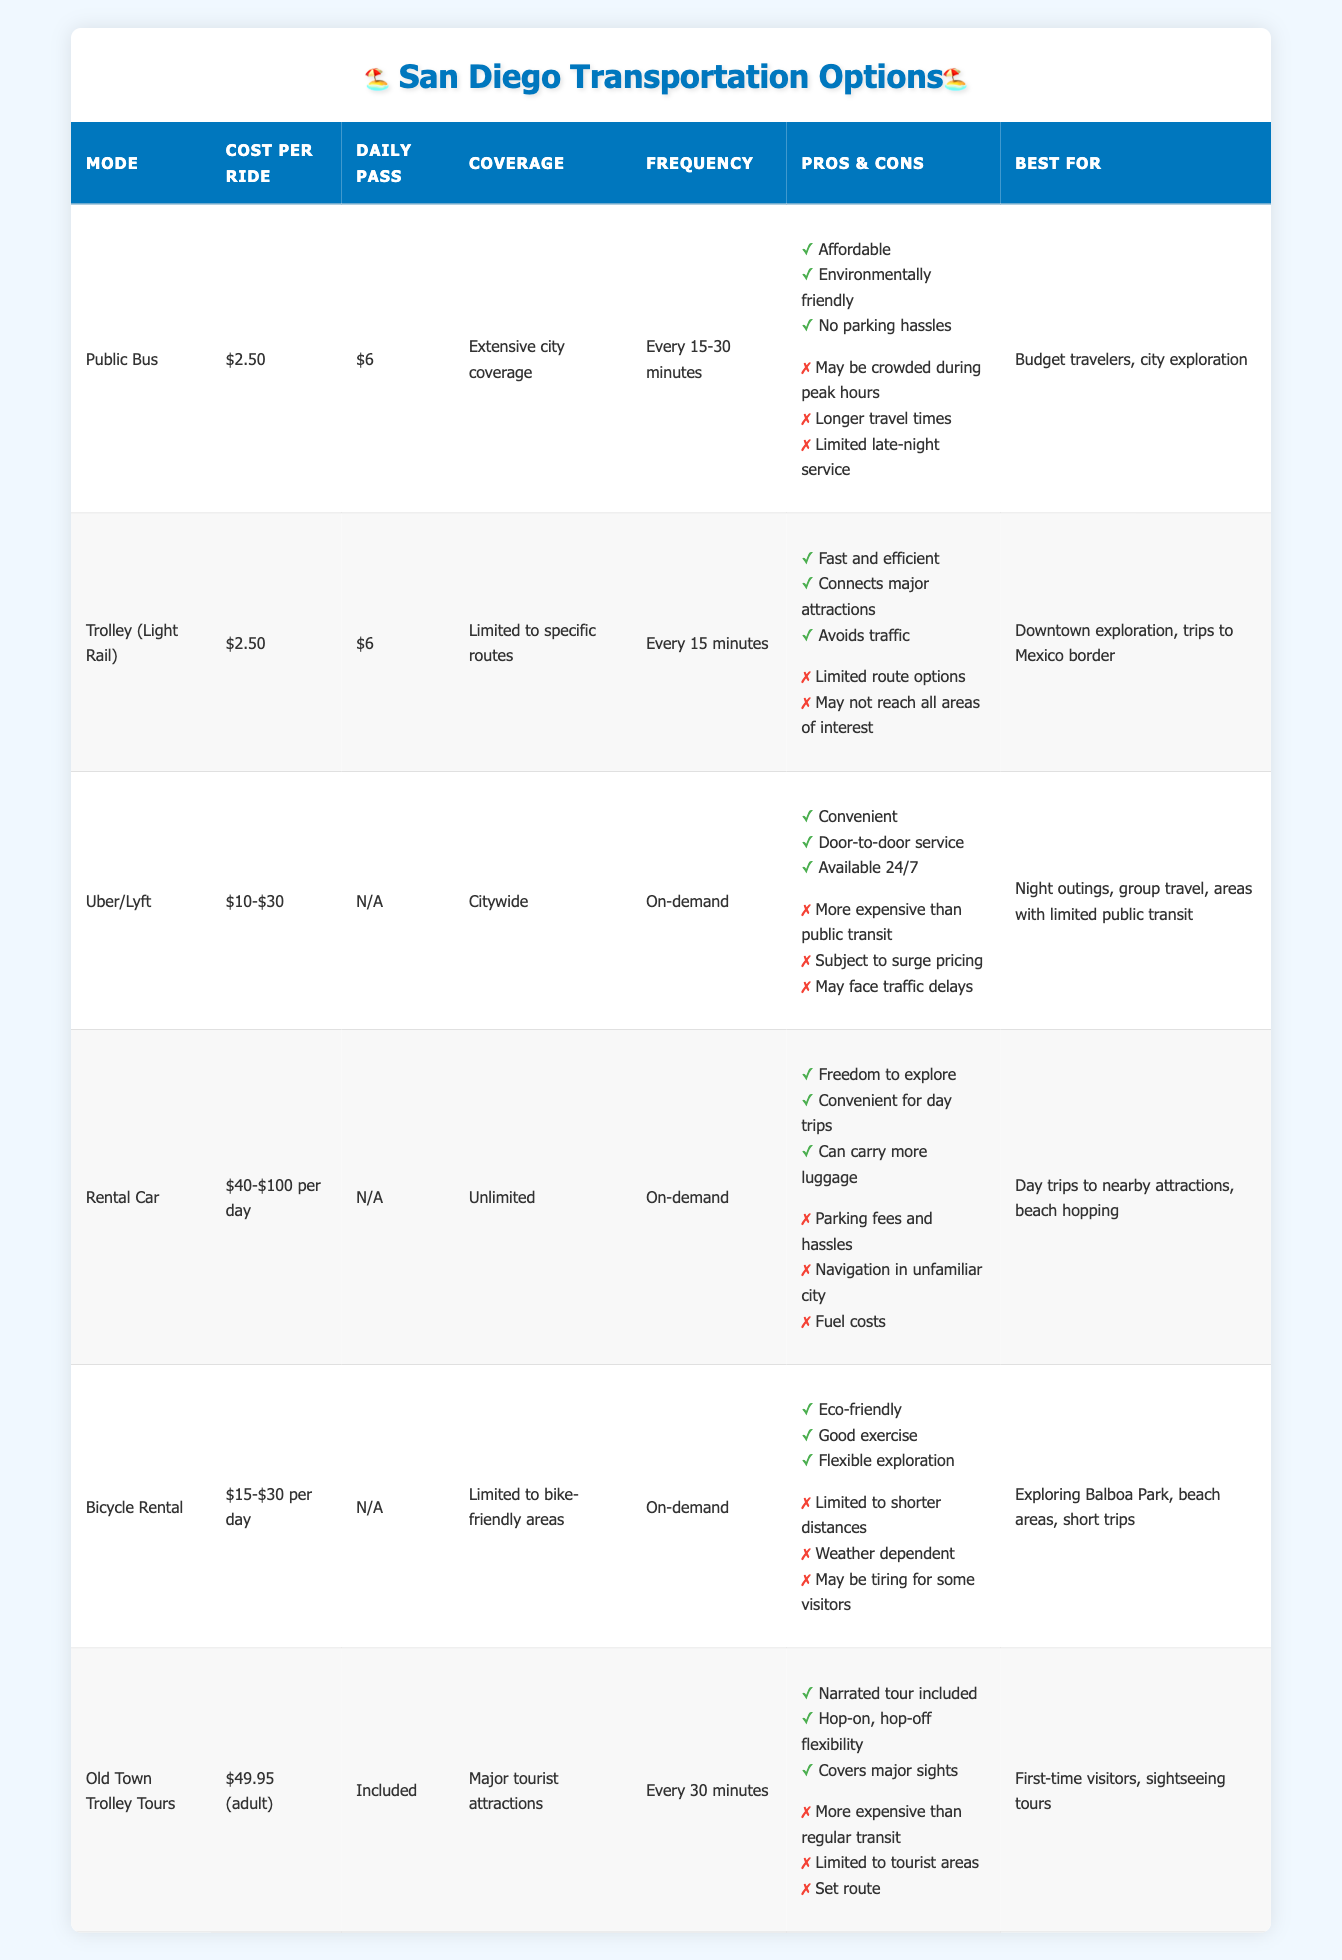What is the cost per ride for the Public Bus? Referring to the table under the "Cost per Ride" column for the row labeled "Public Bus," the value given is $2.50.
Answer: $2.50 Which transportation option has the highest cost per ride? Looking at the "Cost per Ride" column, the highest value is found in the "Rental Car" row, which lists $40-$100 per day. This is greater than all other options.
Answer: Rental Car Does the Trolley (Light Rail) have daily passes? By checking the "Daily Pass" column for the "Trolley (Light Rail)" row, it shows $6, which indicates that it does have a daily pass option available.
Answer: Yes What is the frequency of the Old Town Trolley Tours? In the table under the “Frequency” column, the frequency for "Old Town Trolley Tours" is listed as "Every 30 minutes."
Answer: Every 30 minutes How much more expensive is the Uber/Lyft service compared to the Public Bus cost per ride? The cost for Uber/Lyft is between $10 and $30, while the Public Bus is $2.50. Taking the lowest Uber/Lyft cost of $10 and subtracting the Public Bus cost gives $10 - $2.50 = $7.50. The highest difference with $30 would be $30 - $2.50 = $27.50. Thus, Uber/Lyft is between $7.50 and $27.50 more expensive than the Public Bus.
Answer: $7.50 to $27.50 Which transportation option is best for sightseeing tours? By looking at the "Best For" column, "Old Town Trolley Tours" is specifically labeled for "First-time visitors, sightseeing tours," indicating that it's the best choice for this purpose.
Answer: Old Town Trolley Tours 